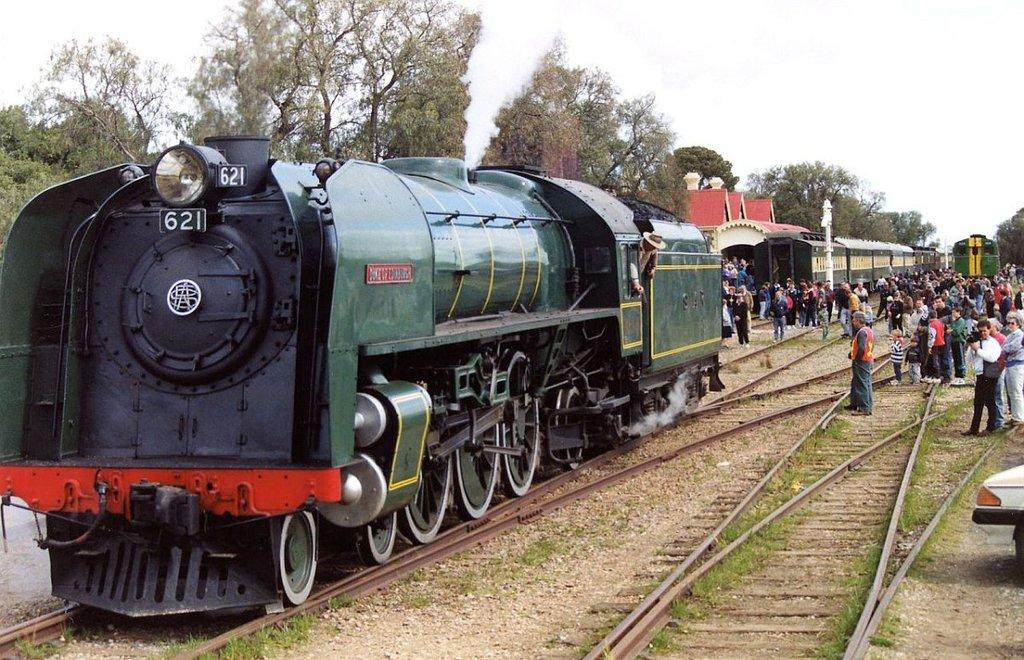What can be seen on the railway tracks in the image? There are trains on the railway tracks in the image. What else is present in the image besides the trains? There is a group of people standing in the image, as well as trees. What can be seen in the background of the image? The sky is visible in the background of the image. What type of suit is the cushion wearing in the image? There is no suit or cushion present in the image. Can you hear thunder in the image? There is no sound or indication of thunder in the image. 